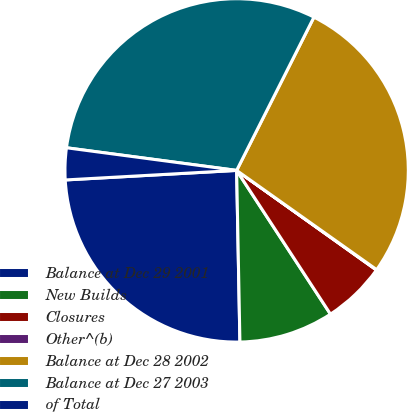Convert chart to OTSL. <chart><loc_0><loc_0><loc_500><loc_500><pie_chart><fcel>Balance at Dec 29 2001<fcel>New Builds<fcel>Closures<fcel>Other^(b)<fcel>Balance at Dec 28 2002<fcel>Balance at Dec 27 2003<fcel>of Total<nl><fcel>24.42%<fcel>8.9%<fcel>5.94%<fcel>0.04%<fcel>27.38%<fcel>30.33%<fcel>2.99%<nl></chart> 